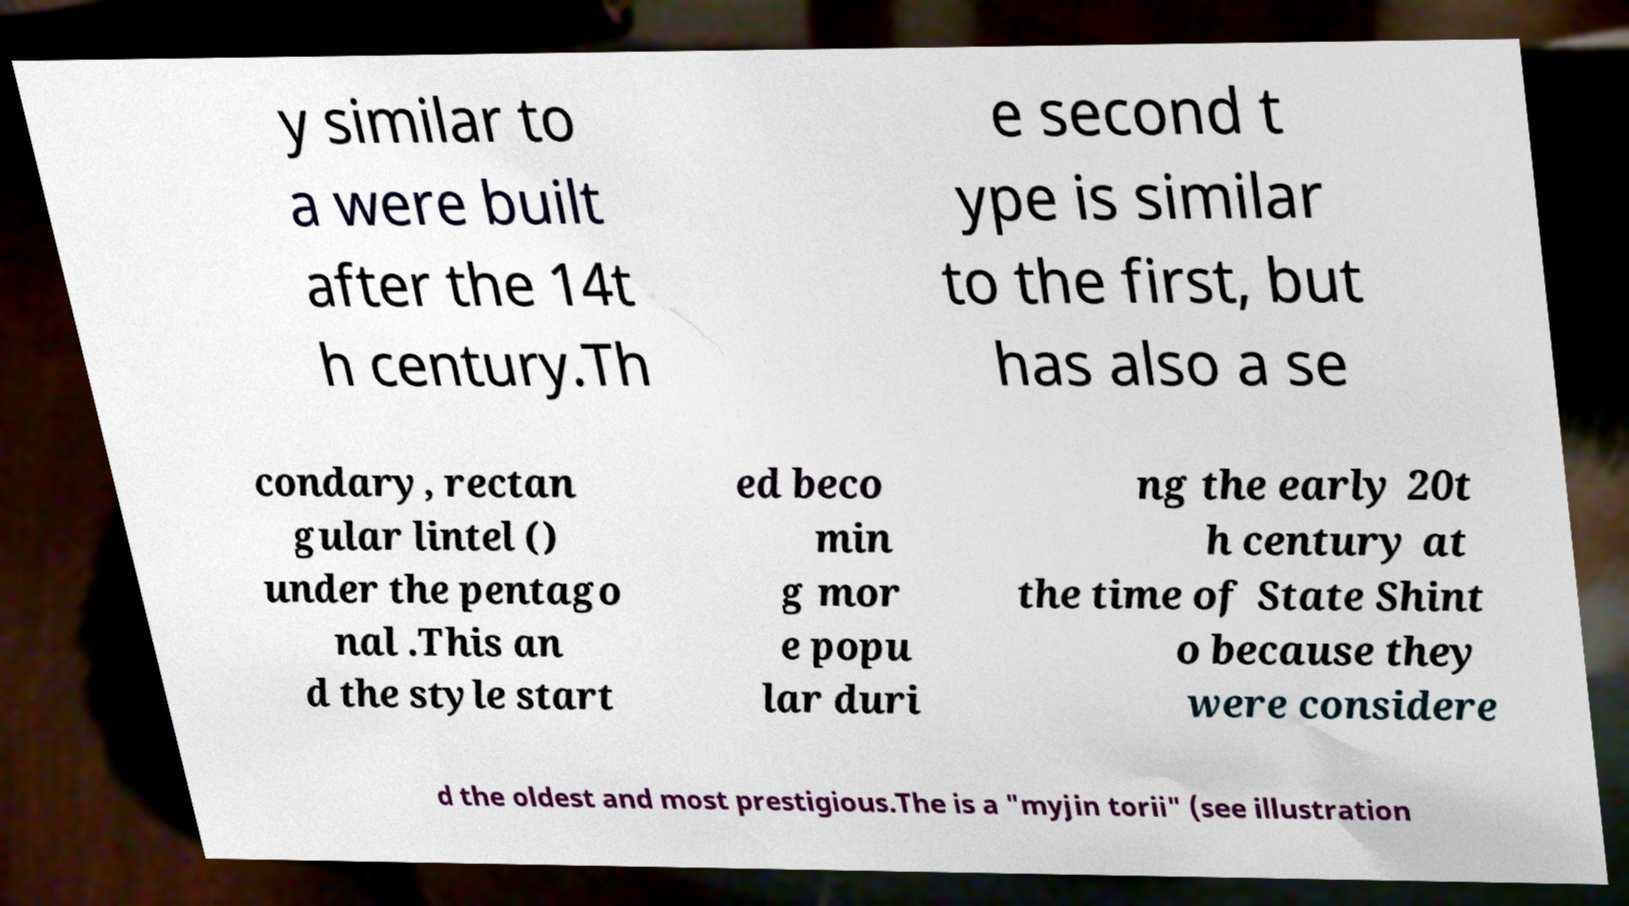What messages or text are displayed in this image? I need them in a readable, typed format. y similar to a were built after the 14t h century.Th e second t ype is similar to the first, but has also a se condary, rectan gular lintel () under the pentago nal .This an d the style start ed beco min g mor e popu lar duri ng the early 20t h century at the time of State Shint o because they were considere d the oldest and most prestigious.The is a "myjin torii" (see illustration 